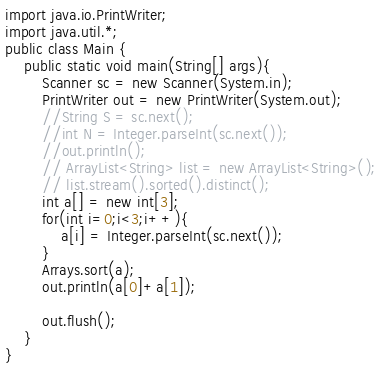Convert code to text. <code><loc_0><loc_0><loc_500><loc_500><_Java_>import java.io.PrintWriter;
import java.util.*;
public class Main {
	public static void main(String[] args){
		Scanner sc = new Scanner(System.in);
		PrintWriter out = new PrintWriter(System.out);
		//String S = sc.next();
		//int N = Integer.parseInt(sc.next());
		//out.println();
		// ArrayList<String> list = new ArrayList<String>();
		// list.stream().sorted().distinct();
		int a[] = new int[3];
		for(int i=0;i<3;i++){
			a[i] = Integer.parseInt(sc.next());
		}
		Arrays.sort(a);
		out.println(a[0]+a[1]);
		
		out.flush();	
	}
}</code> 